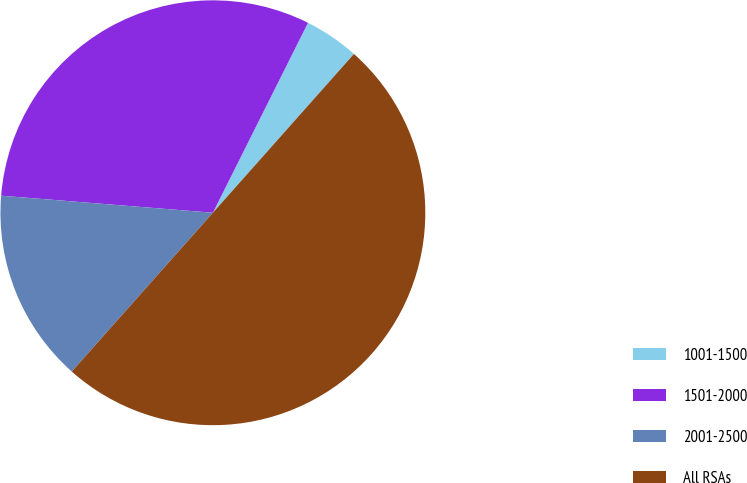Convert chart to OTSL. <chart><loc_0><loc_0><loc_500><loc_500><pie_chart><fcel>1001-1500<fcel>1501-2000<fcel>2001-2500<fcel>All RSAs<nl><fcel>4.17%<fcel>31.11%<fcel>14.72%<fcel>50.0%<nl></chart> 